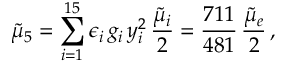<formula> <loc_0><loc_0><loc_500><loc_500>\tilde { \mu } _ { 5 } = \sum _ { i = 1 } ^ { 1 5 } \epsilon _ { i } \, g _ { i } \, y _ { i } ^ { 2 } \, \frac { \tilde { \mu } _ { i } } { 2 } = \frac { 7 1 1 } { 4 8 1 } \, \frac { \tilde { \mu } _ { e } } { 2 } \, ,</formula> 